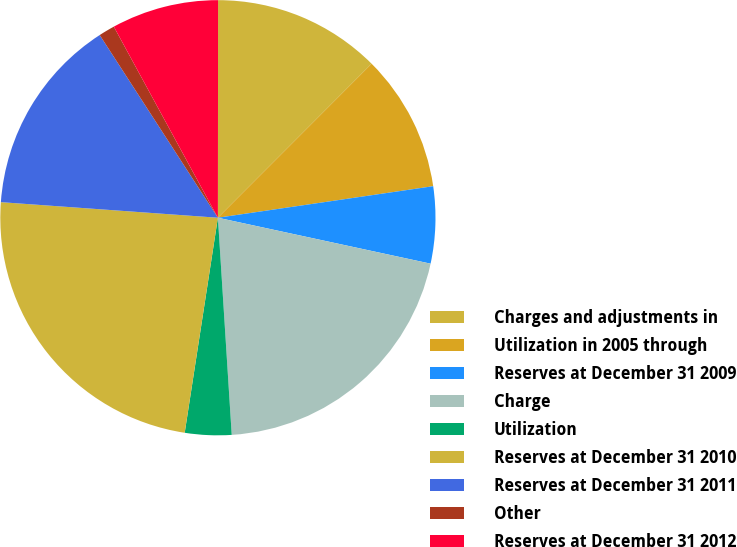Convert chart. <chart><loc_0><loc_0><loc_500><loc_500><pie_chart><fcel>Charges and adjustments in<fcel>Utilization in 2005 through<fcel>Reserves at December 31 2009<fcel>Charge<fcel>Utilization<fcel>Reserves at December 31 2010<fcel>Reserves at December 31 2011<fcel>Other<fcel>Reserves at December 31 2012<nl><fcel>12.47%<fcel>10.2%<fcel>5.7%<fcel>20.6%<fcel>3.45%<fcel>23.7%<fcel>14.72%<fcel>1.2%<fcel>7.95%<nl></chart> 